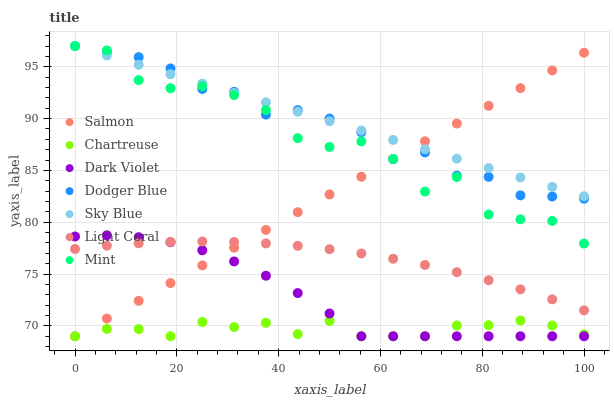Does Chartreuse have the minimum area under the curve?
Answer yes or no. Yes. Does Sky Blue have the maximum area under the curve?
Answer yes or no. Yes. Does Dark Violet have the minimum area under the curve?
Answer yes or no. No. Does Dark Violet have the maximum area under the curve?
Answer yes or no. No. Is Sky Blue the smoothest?
Answer yes or no. Yes. Is Mint the roughest?
Answer yes or no. Yes. Is Dark Violet the smoothest?
Answer yes or no. No. Is Dark Violet the roughest?
Answer yes or no. No. Does Salmon have the lowest value?
Answer yes or no. Yes. Does Light Coral have the lowest value?
Answer yes or no. No. Does Mint have the highest value?
Answer yes or no. Yes. Does Dark Violet have the highest value?
Answer yes or no. No. Is Dark Violet less than Dodger Blue?
Answer yes or no. Yes. Is Sky Blue greater than Chartreuse?
Answer yes or no. Yes. Does Mint intersect Dodger Blue?
Answer yes or no. Yes. Is Mint less than Dodger Blue?
Answer yes or no. No. Is Mint greater than Dodger Blue?
Answer yes or no. No. Does Dark Violet intersect Dodger Blue?
Answer yes or no. No. 